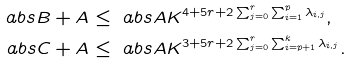Convert formula to latex. <formula><loc_0><loc_0><loc_500><loc_500>\ a b s { B + A } & \leq \ a b s { A } K ^ { 4 + 5 r + 2 \sum _ { j = 0 } ^ { r } \sum _ { i = 1 } ^ { p } \lambda _ { i , j } } , \\ \ a b s { C + A } & \leq \ a b s { A } K ^ { 3 + 5 r + 2 \sum _ { j = 0 } ^ { r } \sum _ { i = p + 1 } ^ { k } \lambda _ { i , j } } . \\</formula> 